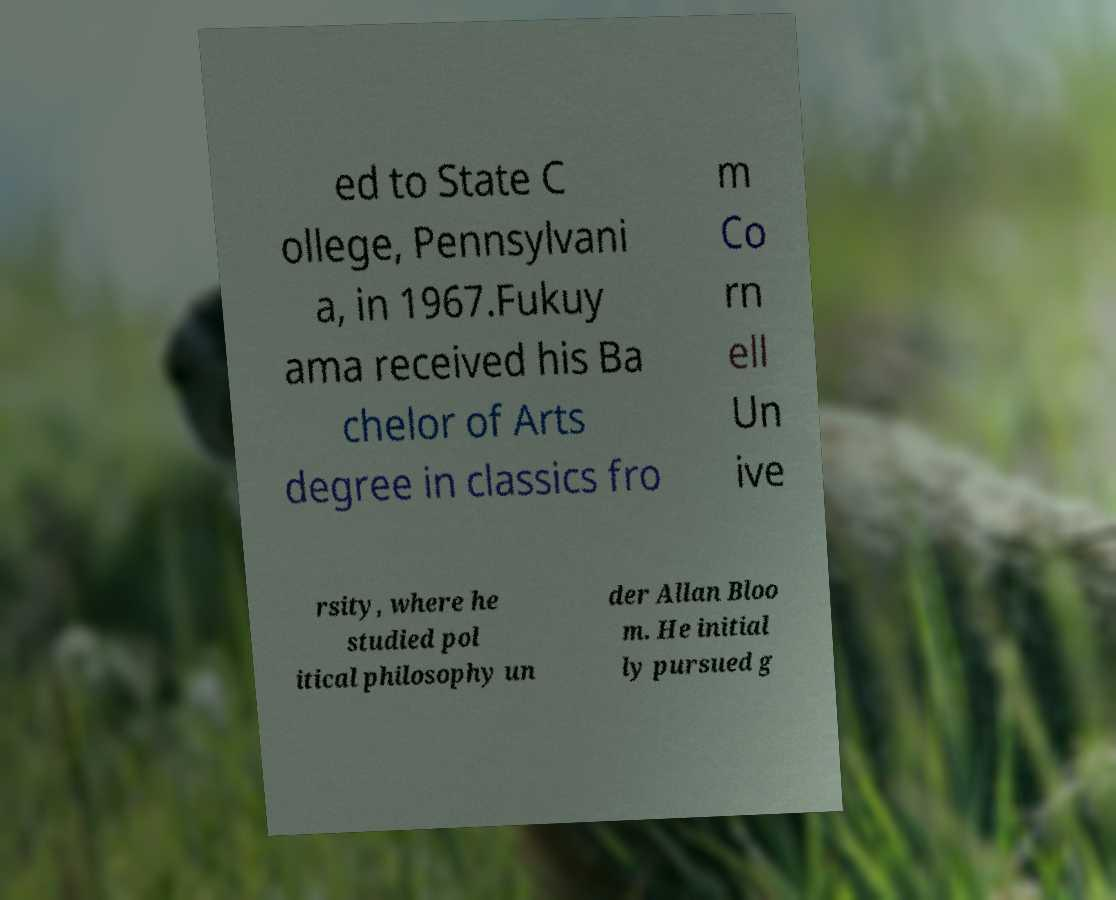What messages or text are displayed in this image? I need them in a readable, typed format. ed to State C ollege, Pennsylvani a, in 1967.Fukuy ama received his Ba chelor of Arts degree in classics fro m Co rn ell Un ive rsity, where he studied pol itical philosophy un der Allan Bloo m. He initial ly pursued g 